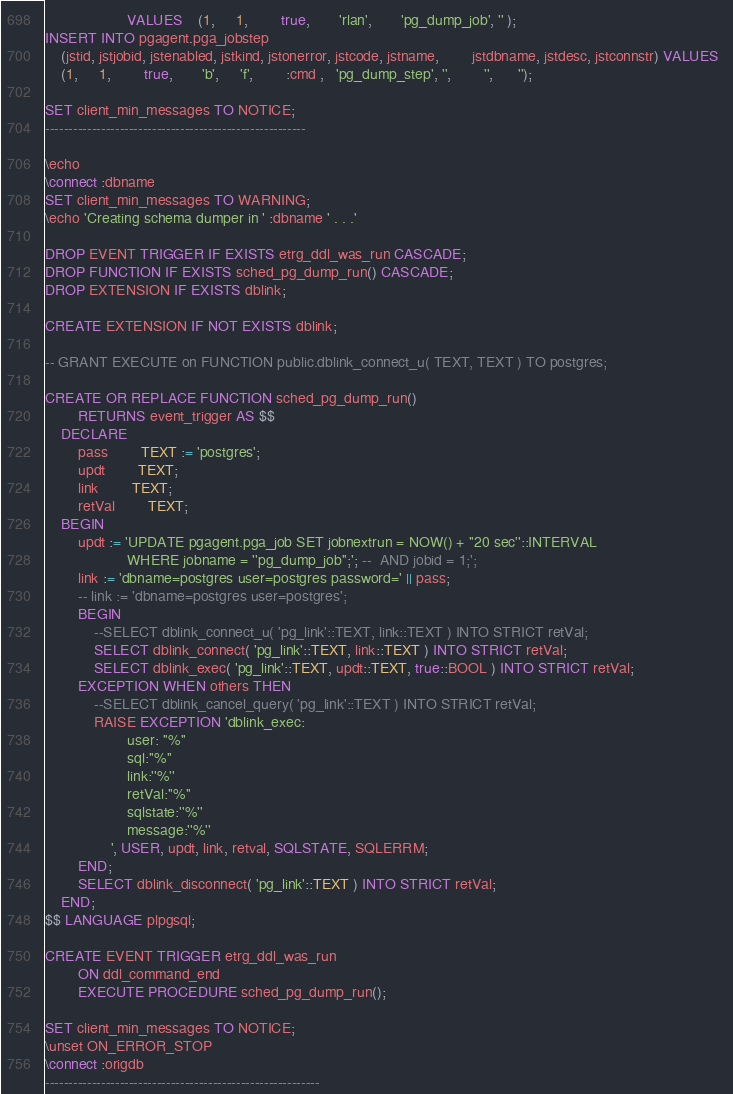Convert code to text. <code><loc_0><loc_0><loc_500><loc_500><_SQL_>					VALUES	(1,     1,        true,       'rlan',       'pg_dump_job', '' );
INSERT INTO pgagent.pga_jobstep 
	(jstid, jstjobid, jstenabled, jstkind, jstonerror, jstcode, jstname,        jstdbname, jstdesc, jstconnstr) VALUES  
	(1,     1,        true,       'b',     'f',        :cmd ,   'pg_dump_step', '',        '',      '');

SET client_min_messages TO NOTICE;
--------------------------------------------------------

\echo
\connect :dbname
SET client_min_messages TO WARNING;
\echo 'Creating schema dumper in ' :dbname ' . . .'

DROP EVENT TRIGGER IF EXISTS etrg_ddl_was_run CASCADE;
DROP FUNCTION IF EXISTS sched_pg_dump_run() CASCADE;
DROP EXTENSION IF EXISTS dblink;

CREATE EXTENSION IF NOT EXISTS dblink;

-- GRANT EXECUTE on FUNCTION public.dblink_connect_u( TEXT, TEXT ) TO postgres;

CREATE OR REPLACE FUNCTION sched_pg_dump_run()
		RETURNS event_trigger AS $$
	DECLARE	
		pass 		TEXT := 'postgres';
		updt 		TEXT;
		link 		TEXT;
		retVal 		TEXT;
	BEGIN
		updt := 'UPDATE pgagent.pga_job SET jobnextrun = NOW() + ''20 sec''::INTERVAL 
					WHERE jobname = ''pg_dump_job'';'; --  AND jobid = 1;';
		link := 'dbname=postgres user=postgres password=' || pass; 
		-- link := 'dbname=postgres user=postgres'; 
		BEGIN
			--SELECT dblink_connect_u( 'pg_link'::TEXT, link::TEXT ) INTO STRICT retVal;
			SELECT dblink_connect( 'pg_link'::TEXT, link::TEXT ) INTO STRICT retVal;
			SELECT dblink_exec( 'pg_link'::TEXT, updt::TEXT, true::BOOL ) INTO STRICT retVal;
		EXCEPTION WHEN others THEN	
			--SELECT dblink_cancel_query( 'pg_link'::TEXT ) INTO STRICT retVal;
			RAISE EXCEPTION 'dblink_exec: 
					user: ''%''
					sql:''%''
					link:''%''
					retVal:''%''
					sqlstate:''%''
					message:''%''
				', USER, updt, link, retval, SQLSTATE, SQLERRM;
		END;
		SELECT dblink_disconnect( 'pg_link'::TEXT ) INTO STRICT retVal;
	END; 
$$ LANGUAGE plpgsql;

CREATE EVENT TRIGGER etrg_ddl_was_run 
		ON ddl_command_end 
		EXECUTE PROCEDURE sched_pg_dump_run();

SET client_min_messages TO NOTICE;
\unset ON_ERROR_STOP
\connect :origdb
-----------------------------------------------------------
</code> 